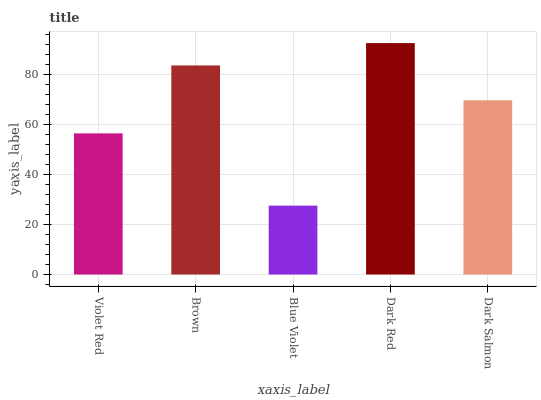Is Blue Violet the minimum?
Answer yes or no. Yes. Is Dark Red the maximum?
Answer yes or no. Yes. Is Brown the minimum?
Answer yes or no. No. Is Brown the maximum?
Answer yes or no. No. Is Brown greater than Violet Red?
Answer yes or no. Yes. Is Violet Red less than Brown?
Answer yes or no. Yes. Is Violet Red greater than Brown?
Answer yes or no. No. Is Brown less than Violet Red?
Answer yes or no. No. Is Dark Salmon the high median?
Answer yes or no. Yes. Is Dark Salmon the low median?
Answer yes or no. Yes. Is Brown the high median?
Answer yes or no. No. Is Dark Red the low median?
Answer yes or no. No. 